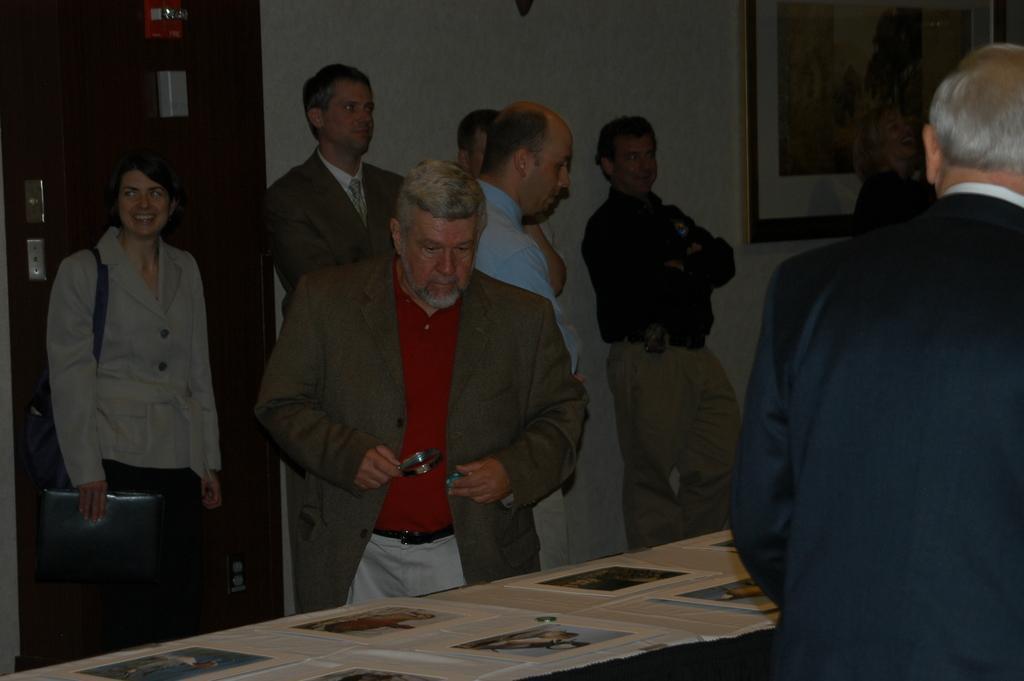Could you give a brief overview of what you see in this image? In this image few persons are standing on the floor. Left side a woman is holding a file in his hand. Behind her there is a door to the wall. A person wearing a suit is standing near the table having few papers on it. Right side there is a person wearing a suit. There is a picture frame attached to the wall. A fire extinguisher is attached to the door. 